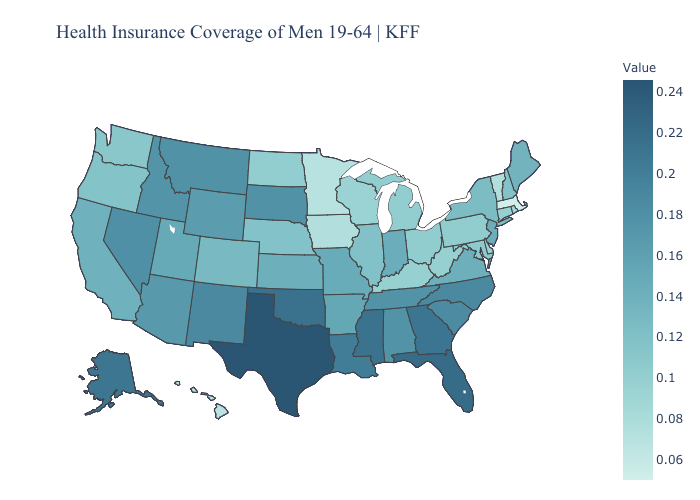Which states have the lowest value in the USA?
Short answer required. Massachusetts. Which states have the lowest value in the South?
Answer briefly. Delaware. Does New York have a lower value than Hawaii?
Write a very short answer. No. Which states have the lowest value in the USA?
Keep it brief. Massachusetts. Which states have the lowest value in the South?
Be succinct. Delaware. Which states have the highest value in the USA?
Answer briefly. Texas. Among the states that border North Carolina , which have the highest value?
Be succinct. Georgia. Is the legend a continuous bar?
Concise answer only. Yes. 